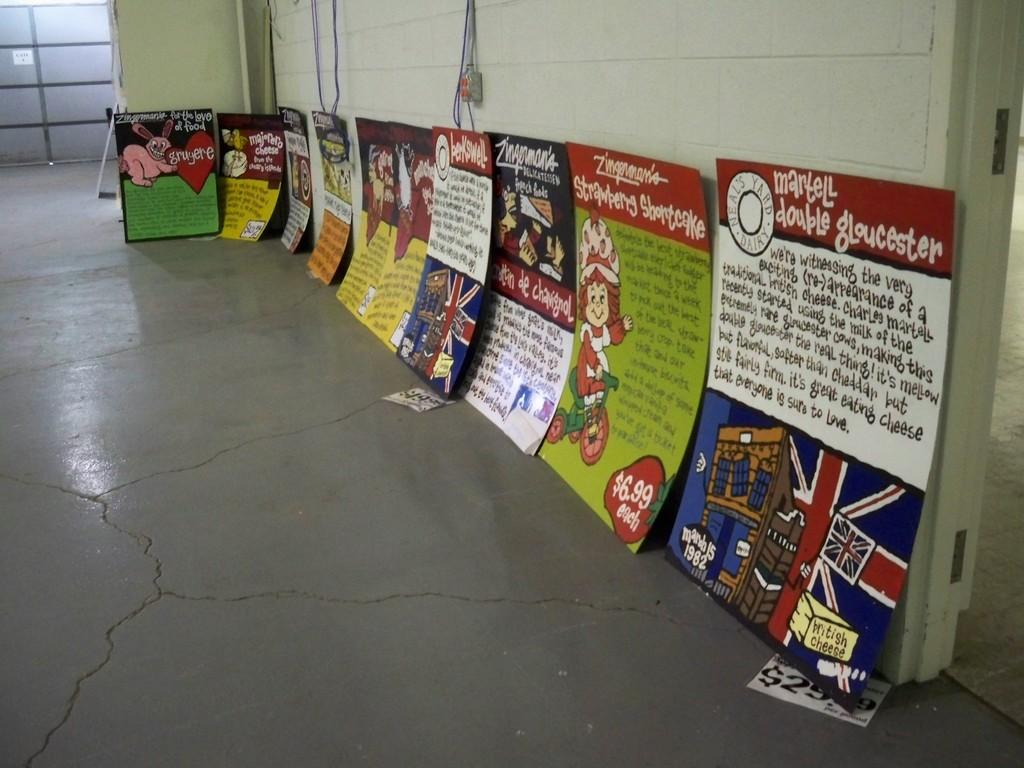<image>
Render a clear and concise summary of the photo. Many signs are leaning against a wall, including one from Neal's Yard Dairy. 